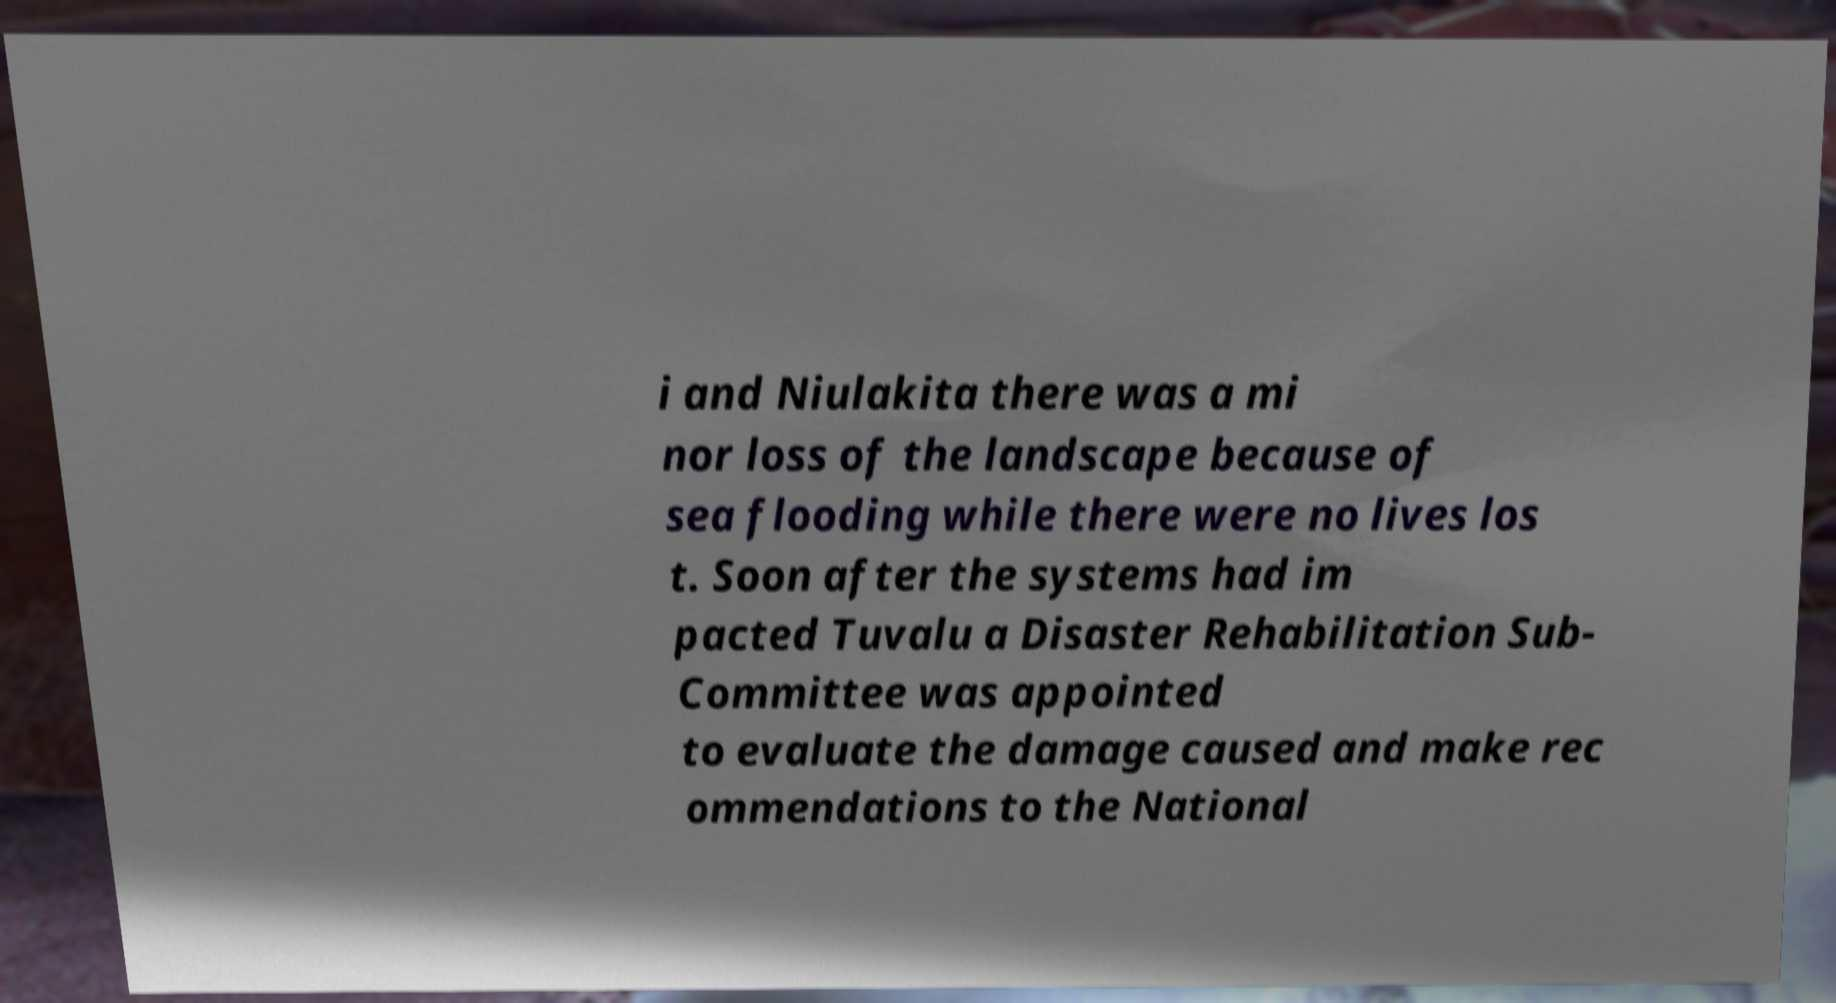Please identify and transcribe the text found in this image. i and Niulakita there was a mi nor loss of the landscape because of sea flooding while there were no lives los t. Soon after the systems had im pacted Tuvalu a Disaster Rehabilitation Sub- Committee was appointed to evaluate the damage caused and make rec ommendations to the National 